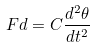Convert formula to latex. <formula><loc_0><loc_0><loc_500><loc_500>F d = C \frac { d ^ { 2 } \theta } { d t ^ { 2 } }</formula> 